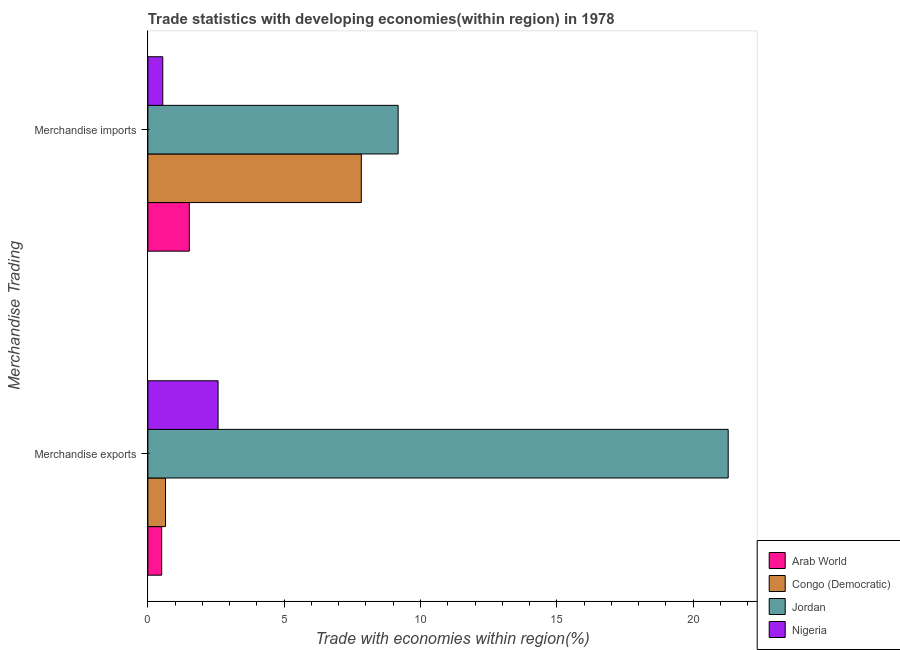Are the number of bars per tick equal to the number of legend labels?
Provide a succinct answer. Yes. Are the number of bars on each tick of the Y-axis equal?
Keep it short and to the point. Yes. How many bars are there on the 2nd tick from the bottom?
Offer a very short reply. 4. What is the label of the 1st group of bars from the top?
Keep it short and to the point. Merchandise imports. What is the merchandise exports in Nigeria?
Provide a succinct answer. 2.58. Across all countries, what is the maximum merchandise imports?
Your answer should be compact. 9.18. Across all countries, what is the minimum merchandise imports?
Keep it short and to the point. 0.55. In which country was the merchandise exports maximum?
Your answer should be compact. Jordan. In which country was the merchandise exports minimum?
Provide a short and direct response. Arab World. What is the total merchandise imports in the graph?
Your answer should be compact. 19.08. What is the difference between the merchandise exports in Nigeria and that in Congo (Democratic)?
Make the answer very short. 1.93. What is the difference between the merchandise exports in Arab World and the merchandise imports in Jordan?
Your answer should be very brief. -8.67. What is the average merchandise imports per country?
Ensure brevity in your answer.  4.77. What is the difference between the merchandise exports and merchandise imports in Jordan?
Your response must be concise. 12.11. In how many countries, is the merchandise exports greater than 11 %?
Keep it short and to the point. 1. What is the ratio of the merchandise imports in Jordan to that in Arab World?
Offer a terse response. 6.04. What does the 4th bar from the top in Merchandise imports represents?
Ensure brevity in your answer.  Arab World. What does the 4th bar from the bottom in Merchandise exports represents?
Provide a succinct answer. Nigeria. What is the difference between two consecutive major ticks on the X-axis?
Ensure brevity in your answer.  5. Does the graph contain grids?
Make the answer very short. No. Where does the legend appear in the graph?
Ensure brevity in your answer.  Bottom right. How many legend labels are there?
Your response must be concise. 4. What is the title of the graph?
Offer a very short reply. Trade statistics with developing economies(within region) in 1978. What is the label or title of the X-axis?
Your answer should be very brief. Trade with economies within region(%). What is the label or title of the Y-axis?
Offer a terse response. Merchandise Trading. What is the Trade with economies within region(%) in Arab World in Merchandise exports?
Ensure brevity in your answer.  0.51. What is the Trade with economies within region(%) of Congo (Democratic) in Merchandise exports?
Ensure brevity in your answer.  0.65. What is the Trade with economies within region(%) of Jordan in Merchandise exports?
Offer a very short reply. 21.29. What is the Trade with economies within region(%) of Nigeria in Merchandise exports?
Make the answer very short. 2.58. What is the Trade with economies within region(%) of Arab World in Merchandise imports?
Provide a short and direct response. 1.52. What is the Trade with economies within region(%) of Congo (Democratic) in Merchandise imports?
Your response must be concise. 7.83. What is the Trade with economies within region(%) of Jordan in Merchandise imports?
Your answer should be compact. 9.18. What is the Trade with economies within region(%) of Nigeria in Merchandise imports?
Your answer should be compact. 0.55. Across all Merchandise Trading, what is the maximum Trade with economies within region(%) in Arab World?
Give a very brief answer. 1.52. Across all Merchandise Trading, what is the maximum Trade with economies within region(%) of Congo (Democratic)?
Offer a very short reply. 7.83. Across all Merchandise Trading, what is the maximum Trade with economies within region(%) of Jordan?
Provide a short and direct response. 21.29. Across all Merchandise Trading, what is the maximum Trade with economies within region(%) in Nigeria?
Offer a very short reply. 2.58. Across all Merchandise Trading, what is the minimum Trade with economies within region(%) in Arab World?
Offer a very short reply. 0.51. Across all Merchandise Trading, what is the minimum Trade with economies within region(%) in Congo (Democratic)?
Offer a very short reply. 0.65. Across all Merchandise Trading, what is the minimum Trade with economies within region(%) in Jordan?
Your response must be concise. 9.18. Across all Merchandise Trading, what is the minimum Trade with economies within region(%) in Nigeria?
Offer a terse response. 0.55. What is the total Trade with economies within region(%) of Arab World in the graph?
Make the answer very short. 2.03. What is the total Trade with economies within region(%) of Congo (Democratic) in the graph?
Give a very brief answer. 8.48. What is the total Trade with economies within region(%) of Jordan in the graph?
Ensure brevity in your answer.  30.47. What is the total Trade with economies within region(%) in Nigeria in the graph?
Provide a short and direct response. 3.12. What is the difference between the Trade with economies within region(%) in Arab World in Merchandise exports and that in Merchandise imports?
Offer a terse response. -1.01. What is the difference between the Trade with economies within region(%) of Congo (Democratic) in Merchandise exports and that in Merchandise imports?
Give a very brief answer. -7.18. What is the difference between the Trade with economies within region(%) in Jordan in Merchandise exports and that in Merchandise imports?
Your response must be concise. 12.11. What is the difference between the Trade with economies within region(%) of Nigeria in Merchandise exports and that in Merchandise imports?
Make the answer very short. 2.03. What is the difference between the Trade with economies within region(%) of Arab World in Merchandise exports and the Trade with economies within region(%) of Congo (Democratic) in Merchandise imports?
Make the answer very short. -7.32. What is the difference between the Trade with economies within region(%) in Arab World in Merchandise exports and the Trade with economies within region(%) in Jordan in Merchandise imports?
Make the answer very short. -8.67. What is the difference between the Trade with economies within region(%) of Arab World in Merchandise exports and the Trade with economies within region(%) of Nigeria in Merchandise imports?
Provide a succinct answer. -0.04. What is the difference between the Trade with economies within region(%) in Congo (Democratic) in Merchandise exports and the Trade with economies within region(%) in Jordan in Merchandise imports?
Offer a very short reply. -8.53. What is the difference between the Trade with economies within region(%) of Congo (Democratic) in Merchandise exports and the Trade with economies within region(%) of Nigeria in Merchandise imports?
Your response must be concise. 0.1. What is the difference between the Trade with economies within region(%) of Jordan in Merchandise exports and the Trade with economies within region(%) of Nigeria in Merchandise imports?
Offer a terse response. 20.74. What is the average Trade with economies within region(%) in Arab World per Merchandise Trading?
Provide a succinct answer. 1.01. What is the average Trade with economies within region(%) in Congo (Democratic) per Merchandise Trading?
Keep it short and to the point. 4.24. What is the average Trade with economies within region(%) in Jordan per Merchandise Trading?
Offer a very short reply. 15.23. What is the average Trade with economies within region(%) in Nigeria per Merchandise Trading?
Your response must be concise. 1.56. What is the difference between the Trade with economies within region(%) of Arab World and Trade with economies within region(%) of Congo (Democratic) in Merchandise exports?
Provide a succinct answer. -0.14. What is the difference between the Trade with economies within region(%) in Arab World and Trade with economies within region(%) in Jordan in Merchandise exports?
Your answer should be very brief. -20.78. What is the difference between the Trade with economies within region(%) in Arab World and Trade with economies within region(%) in Nigeria in Merchandise exports?
Keep it short and to the point. -2.07. What is the difference between the Trade with economies within region(%) of Congo (Democratic) and Trade with economies within region(%) of Jordan in Merchandise exports?
Your answer should be compact. -20.64. What is the difference between the Trade with economies within region(%) in Congo (Democratic) and Trade with economies within region(%) in Nigeria in Merchandise exports?
Offer a terse response. -1.93. What is the difference between the Trade with economies within region(%) of Jordan and Trade with economies within region(%) of Nigeria in Merchandise exports?
Offer a very short reply. 18.71. What is the difference between the Trade with economies within region(%) in Arab World and Trade with economies within region(%) in Congo (Democratic) in Merchandise imports?
Your response must be concise. -6.31. What is the difference between the Trade with economies within region(%) in Arab World and Trade with economies within region(%) in Jordan in Merchandise imports?
Ensure brevity in your answer.  -7.66. What is the difference between the Trade with economies within region(%) in Arab World and Trade with economies within region(%) in Nigeria in Merchandise imports?
Offer a terse response. 0.97. What is the difference between the Trade with economies within region(%) of Congo (Democratic) and Trade with economies within region(%) of Jordan in Merchandise imports?
Keep it short and to the point. -1.35. What is the difference between the Trade with economies within region(%) in Congo (Democratic) and Trade with economies within region(%) in Nigeria in Merchandise imports?
Keep it short and to the point. 7.28. What is the difference between the Trade with economies within region(%) in Jordan and Trade with economies within region(%) in Nigeria in Merchandise imports?
Your answer should be compact. 8.63. What is the ratio of the Trade with economies within region(%) in Arab World in Merchandise exports to that in Merchandise imports?
Provide a short and direct response. 0.33. What is the ratio of the Trade with economies within region(%) of Congo (Democratic) in Merchandise exports to that in Merchandise imports?
Ensure brevity in your answer.  0.08. What is the ratio of the Trade with economies within region(%) in Jordan in Merchandise exports to that in Merchandise imports?
Your answer should be compact. 2.32. What is the ratio of the Trade with economies within region(%) in Nigeria in Merchandise exports to that in Merchandise imports?
Give a very brief answer. 4.71. What is the difference between the highest and the second highest Trade with economies within region(%) of Arab World?
Offer a terse response. 1.01. What is the difference between the highest and the second highest Trade with economies within region(%) of Congo (Democratic)?
Make the answer very short. 7.18. What is the difference between the highest and the second highest Trade with economies within region(%) in Jordan?
Provide a succinct answer. 12.11. What is the difference between the highest and the second highest Trade with economies within region(%) in Nigeria?
Provide a succinct answer. 2.03. What is the difference between the highest and the lowest Trade with economies within region(%) of Arab World?
Ensure brevity in your answer.  1.01. What is the difference between the highest and the lowest Trade with economies within region(%) of Congo (Democratic)?
Make the answer very short. 7.18. What is the difference between the highest and the lowest Trade with economies within region(%) of Jordan?
Your answer should be compact. 12.11. What is the difference between the highest and the lowest Trade with economies within region(%) of Nigeria?
Offer a terse response. 2.03. 